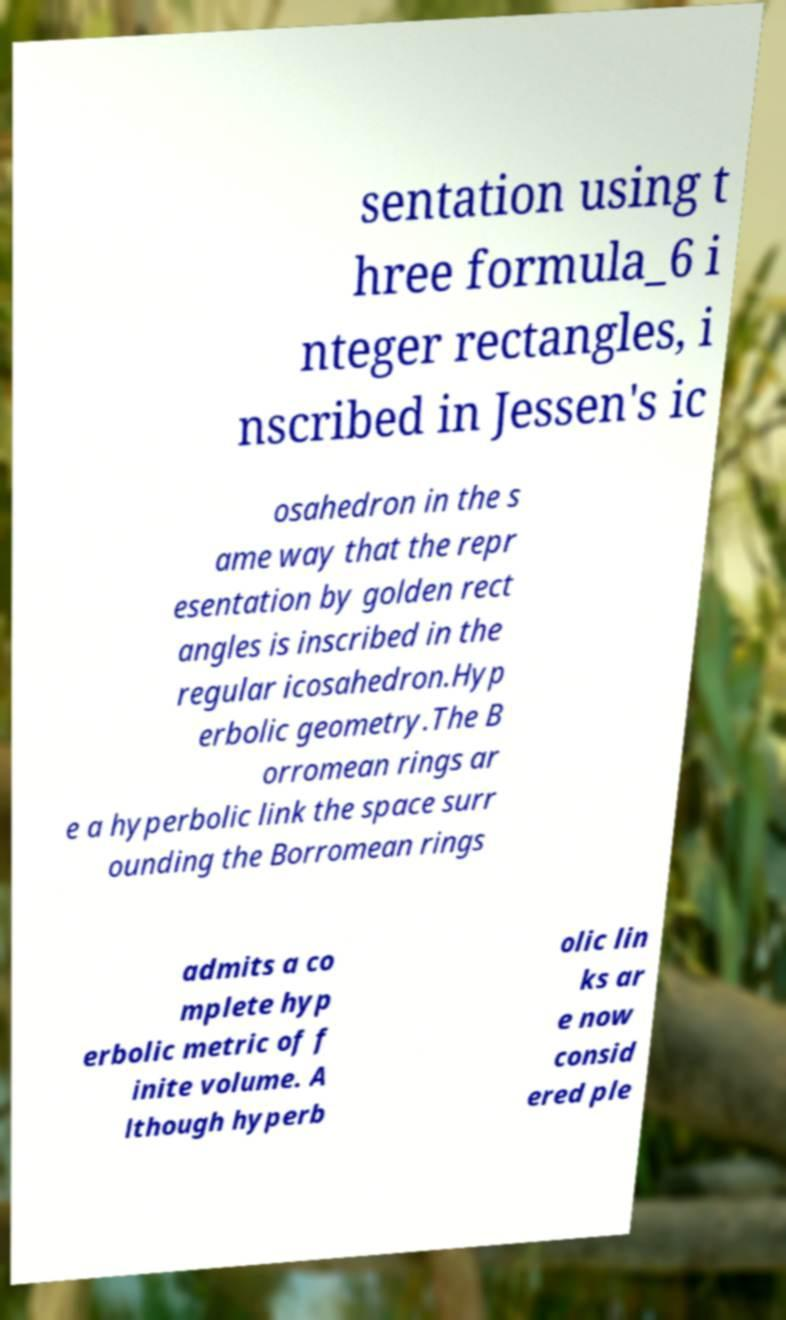Please identify and transcribe the text found in this image. sentation using t hree formula_6 i nteger rectangles, i nscribed in Jessen's ic osahedron in the s ame way that the repr esentation by golden rect angles is inscribed in the regular icosahedron.Hyp erbolic geometry.The B orromean rings ar e a hyperbolic link the space surr ounding the Borromean rings admits a co mplete hyp erbolic metric of f inite volume. A lthough hyperb olic lin ks ar e now consid ered ple 